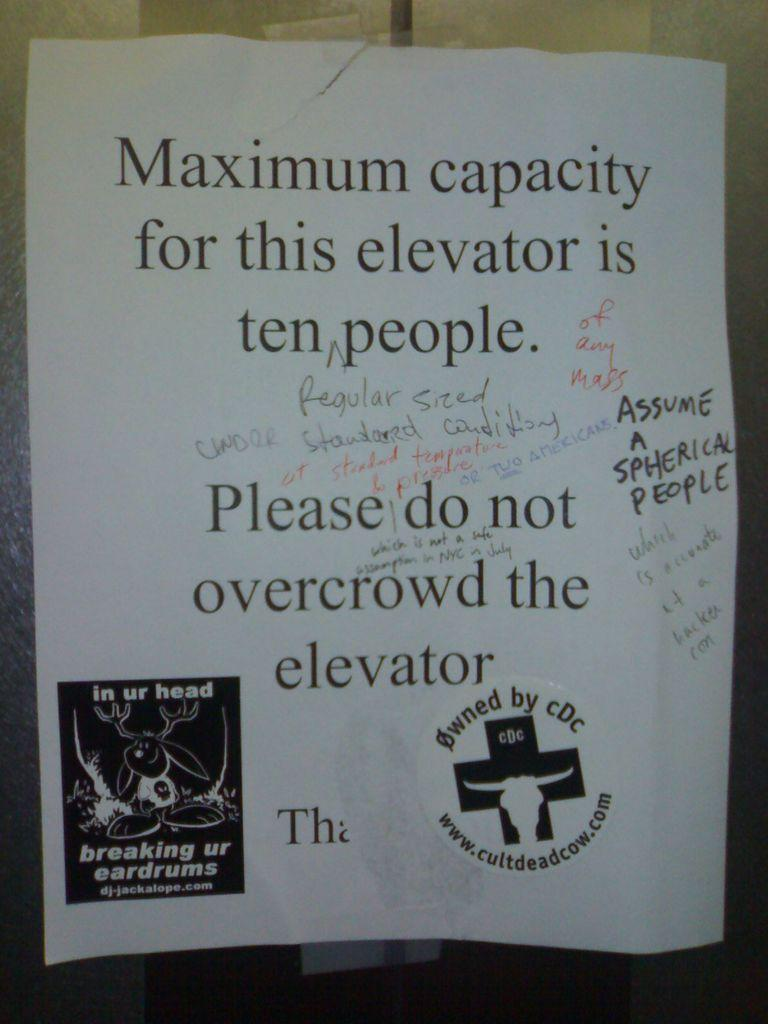<image>
Create a compact narrative representing the image presented. People have written on a sign that warns to not overcrowd the elevator. 